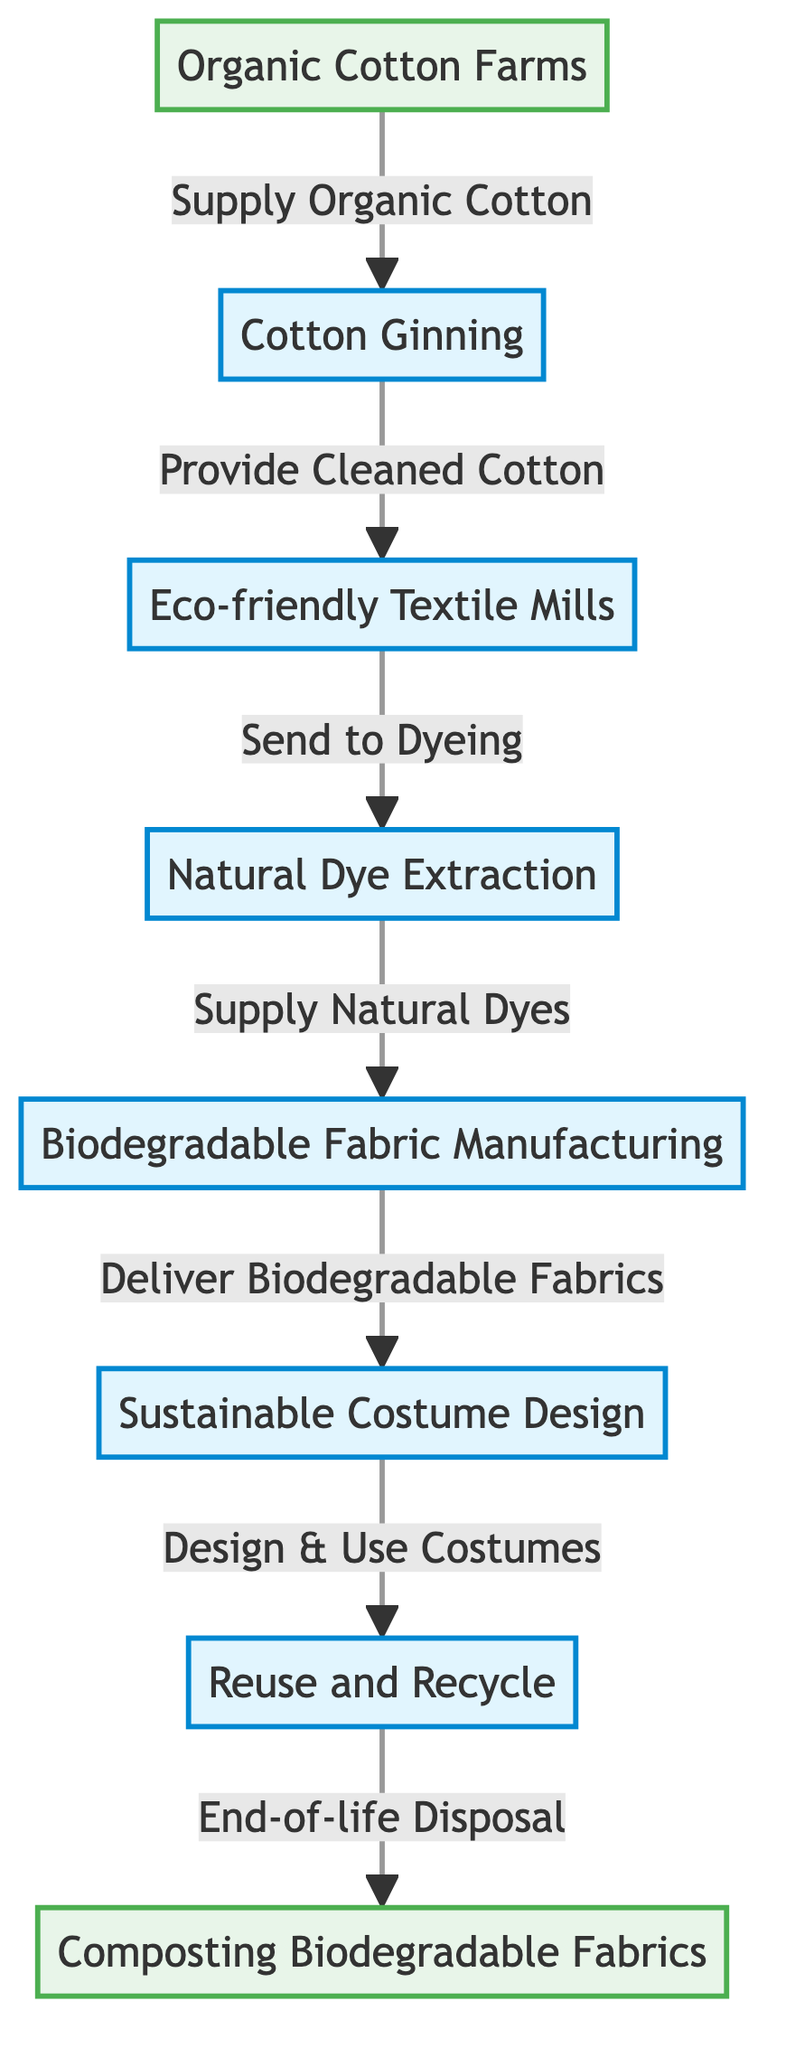What is the starting point of the food chain? The first node in the food chain is "Organic Cotton Farms," indicated as the starting point that supplies organic cotton.
Answer: Organic Cotton Farms How many steps are there in the food chain? Counting each node from the starting point to the end, there are a total of 7 steps in the food chain.
Answer: 7 Which process comes after cotton ginning? The process that follows cotton ginning is "Eco-friendly Textile Mills," as indicated by the flow from the ginning stage.
Answer: Eco-friendly Textile Mills What do textile mills send to after processing? Textile mills send their output to the "Natural Dye Extraction" process for dyeing, which is the next step in the chain.
Answer: Natural Dye Extraction What is the end-of-life disposal method for costumes? The end-of-life disposal method indicated for costumes is "Composting Biodegradable Fabrics," shown as the last process in the chain.
Answer: Composting Biodegradable Fabrics How many eco-friendly processes are involved before costume design? There are 4 eco-friendly processes involved before reaching the "Sustainable Costume Design" stage: cotton ginning, eco-friendly textile mills, natural dye extraction, and biodegradable fabric manufacturing.
Answer: 4 What is supplied to fabric manufacturing? The fabric manufacturing stage is supplied with "Natural Dyes," which are provided by the natural dye extraction process.
Answer: Natural Dyes What happens after sustainable costume design? Following sustainable costume design, the next process is "Reuse and Recycle," where costumes are reused or recycled after their initial use.
Answer: Reuse and Recycle Which two nodes are endpoint nodes in the diagram? The two endpoint nodes indicated in the diagram are "Organic Cotton Farms" and "Composting Biodegradable Fabrics."
Answer: Organic Cotton Farms, Composting Biodegradable Fabrics 